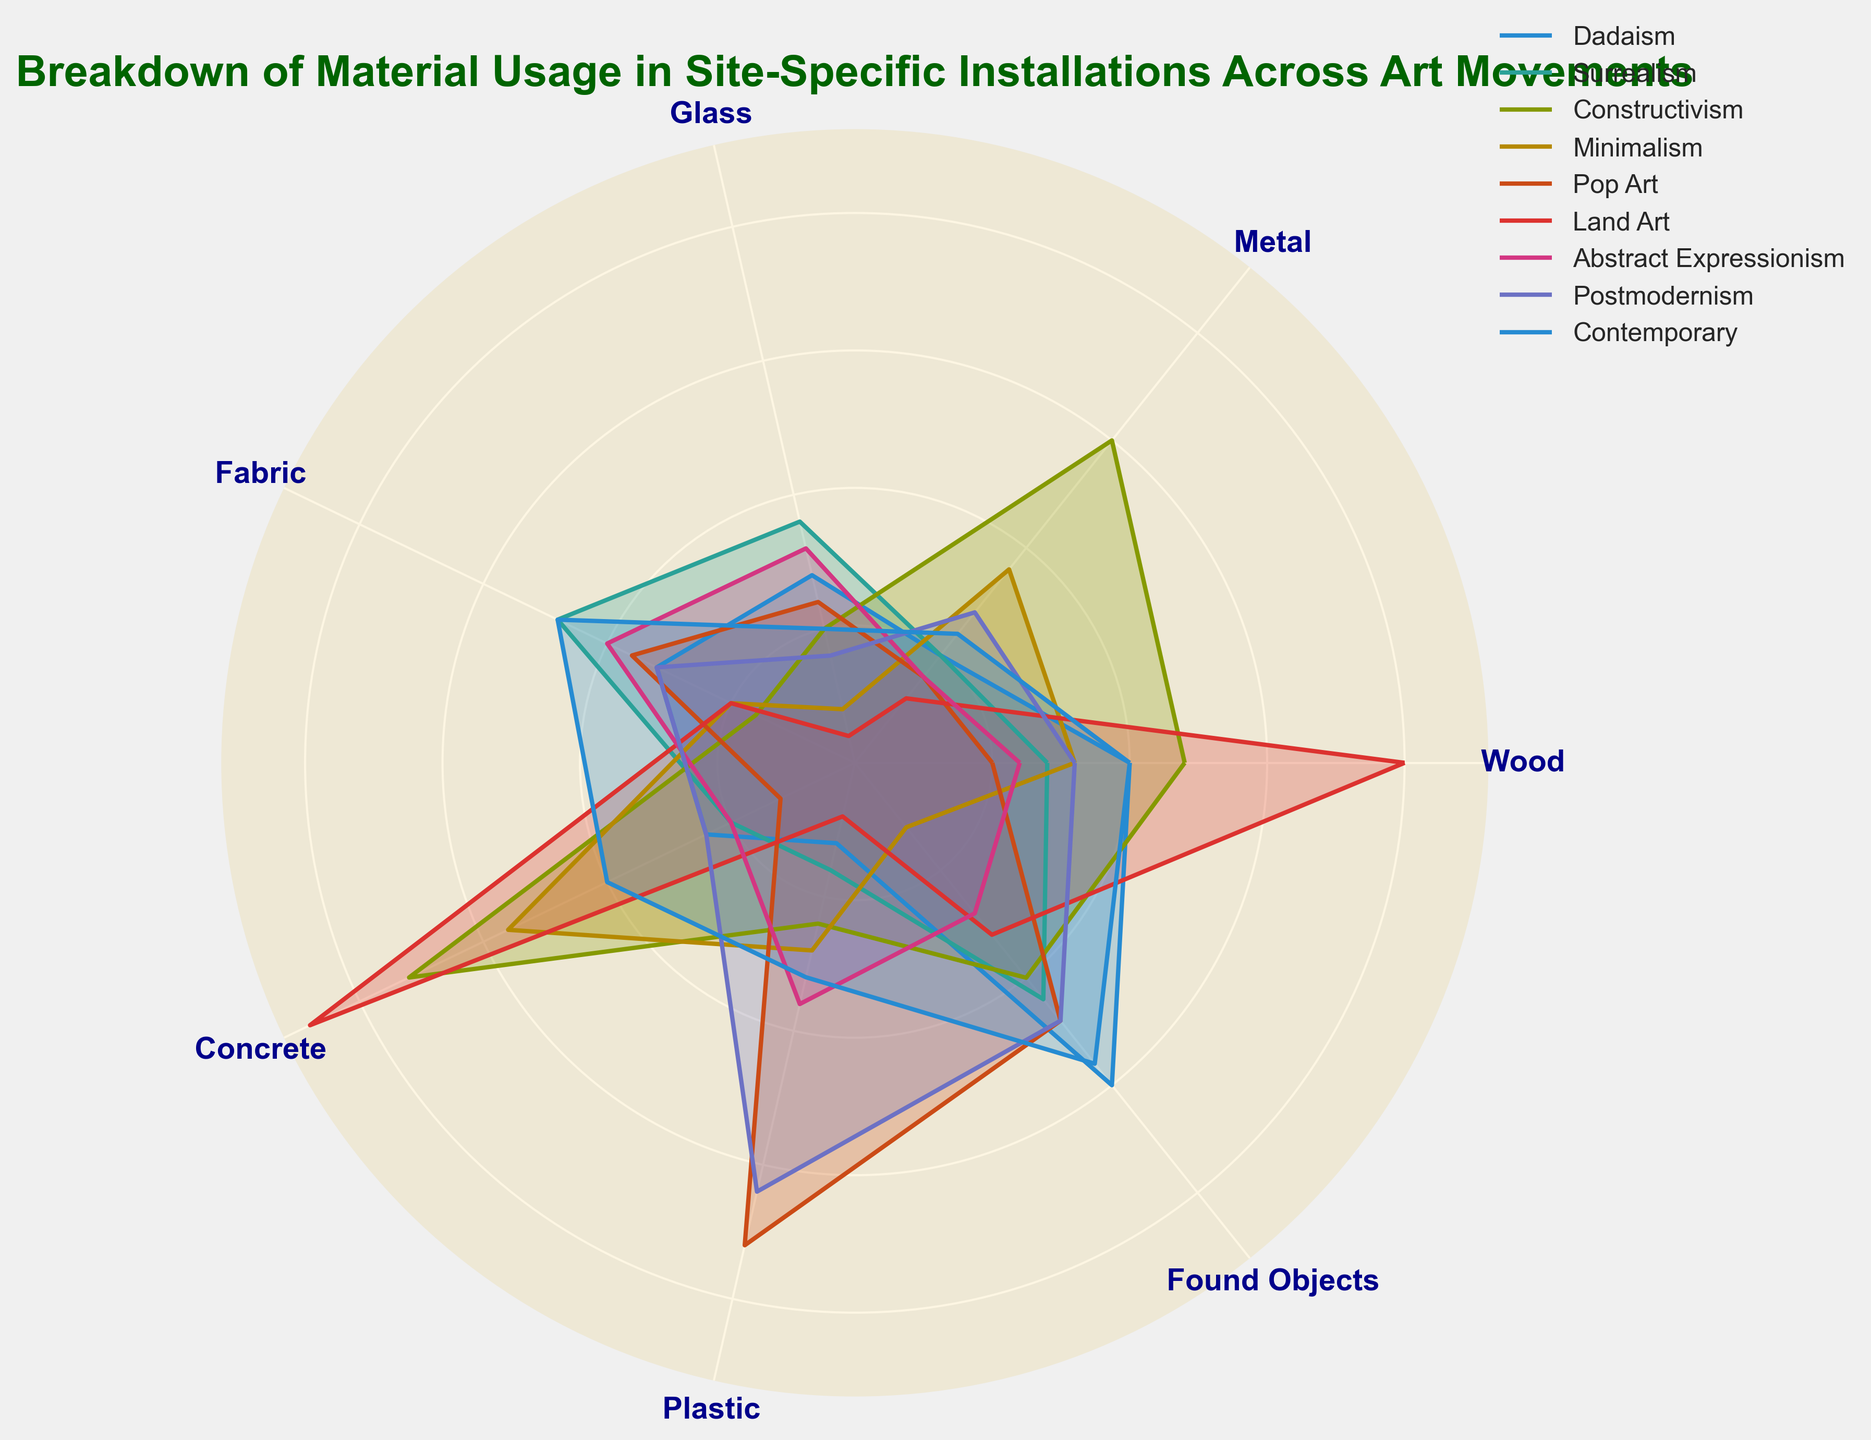Which art movement uses the most Wood? By examining the radar chart, look for the art movement that has the longest segment in the Wood category.
Answer: Land Art Which art movement has a higher usage of Fabric, Surrealism or Pop Art? Compare the length of the segments for Fabric in both Surrealism and Pop Art.
Answer: Surrealism What is the total combined usage of Metal and Plastic for Constructivism? Add the values of Metal and Plastic for Constructivism: 15 (Metal) + 6 (Plastic) = 21.
Answer: 21 Which art movement uses the least amount of Concrete? Find the art movement with the shortest segment in the Concrete category.
Answer: Pop Art Is the usage of Glass in Abstract Expressionism equal to the usage of Glass in Contemporary? Compare the lengths of the segments for Glass in Abstract Expressionism and Contemporary.
Answer: No Which art movement uses more Found Objects, Postmodernism or Contemporary? Compare the lengths of the segments for Found Objects in both Postmodernism and Contemporary.
Answer: Contemporary What is the average usage of Metal across all art movements? Sum the usage of Metal in all art movements and divide by the number of art movements. (5 + 5 + 15 + 9 + 4 + 3 + 4 + 7 + 6) / 9 = 7.555.
Answer: 7.555 Does Minimalism use more Metal or Concrete? Compare the lengths of the segments for Metal and Concrete in Minimalism.
Answer: Concrete What is the difference in usage of Found Objects between Dadaism and Pop Art? Subtract the usage of Found Objects in Pop Art from Dadaism: 15 (Dadaism) - 12 (Pop Art) = 3.
Answer: 3 